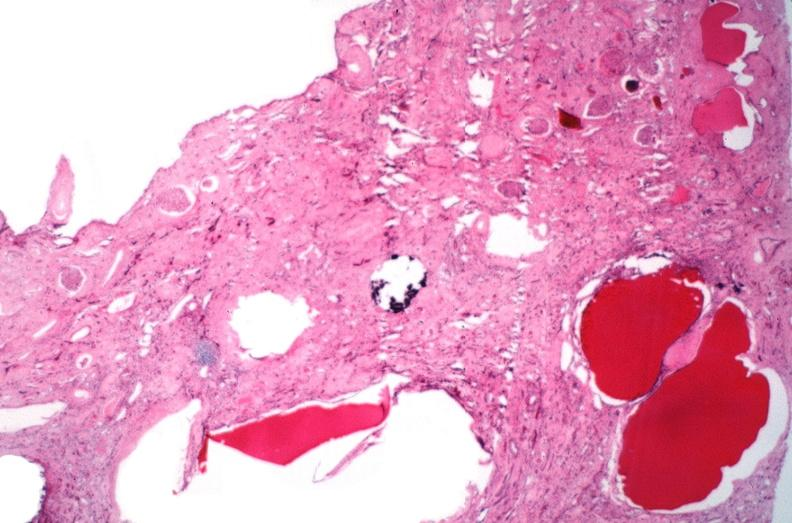where is this?
Answer the question using a single word or phrase. Urinary 